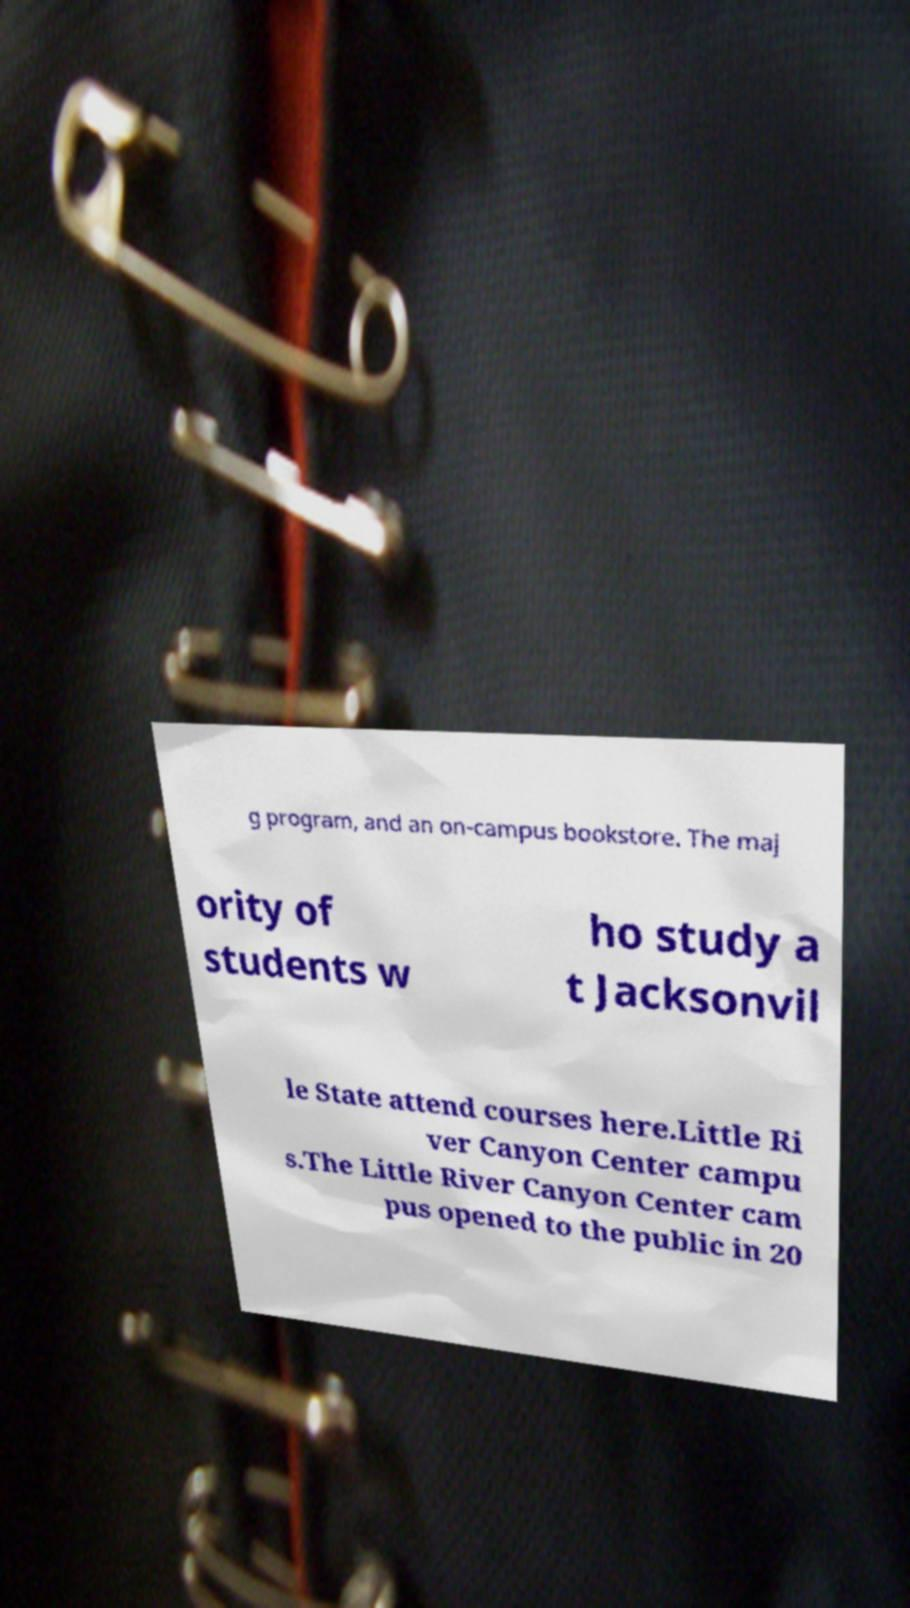Please identify and transcribe the text found in this image. g program, and an on-campus bookstore. The maj ority of students w ho study a t Jacksonvil le State attend courses here.Little Ri ver Canyon Center campu s.The Little River Canyon Center cam pus opened to the public in 20 